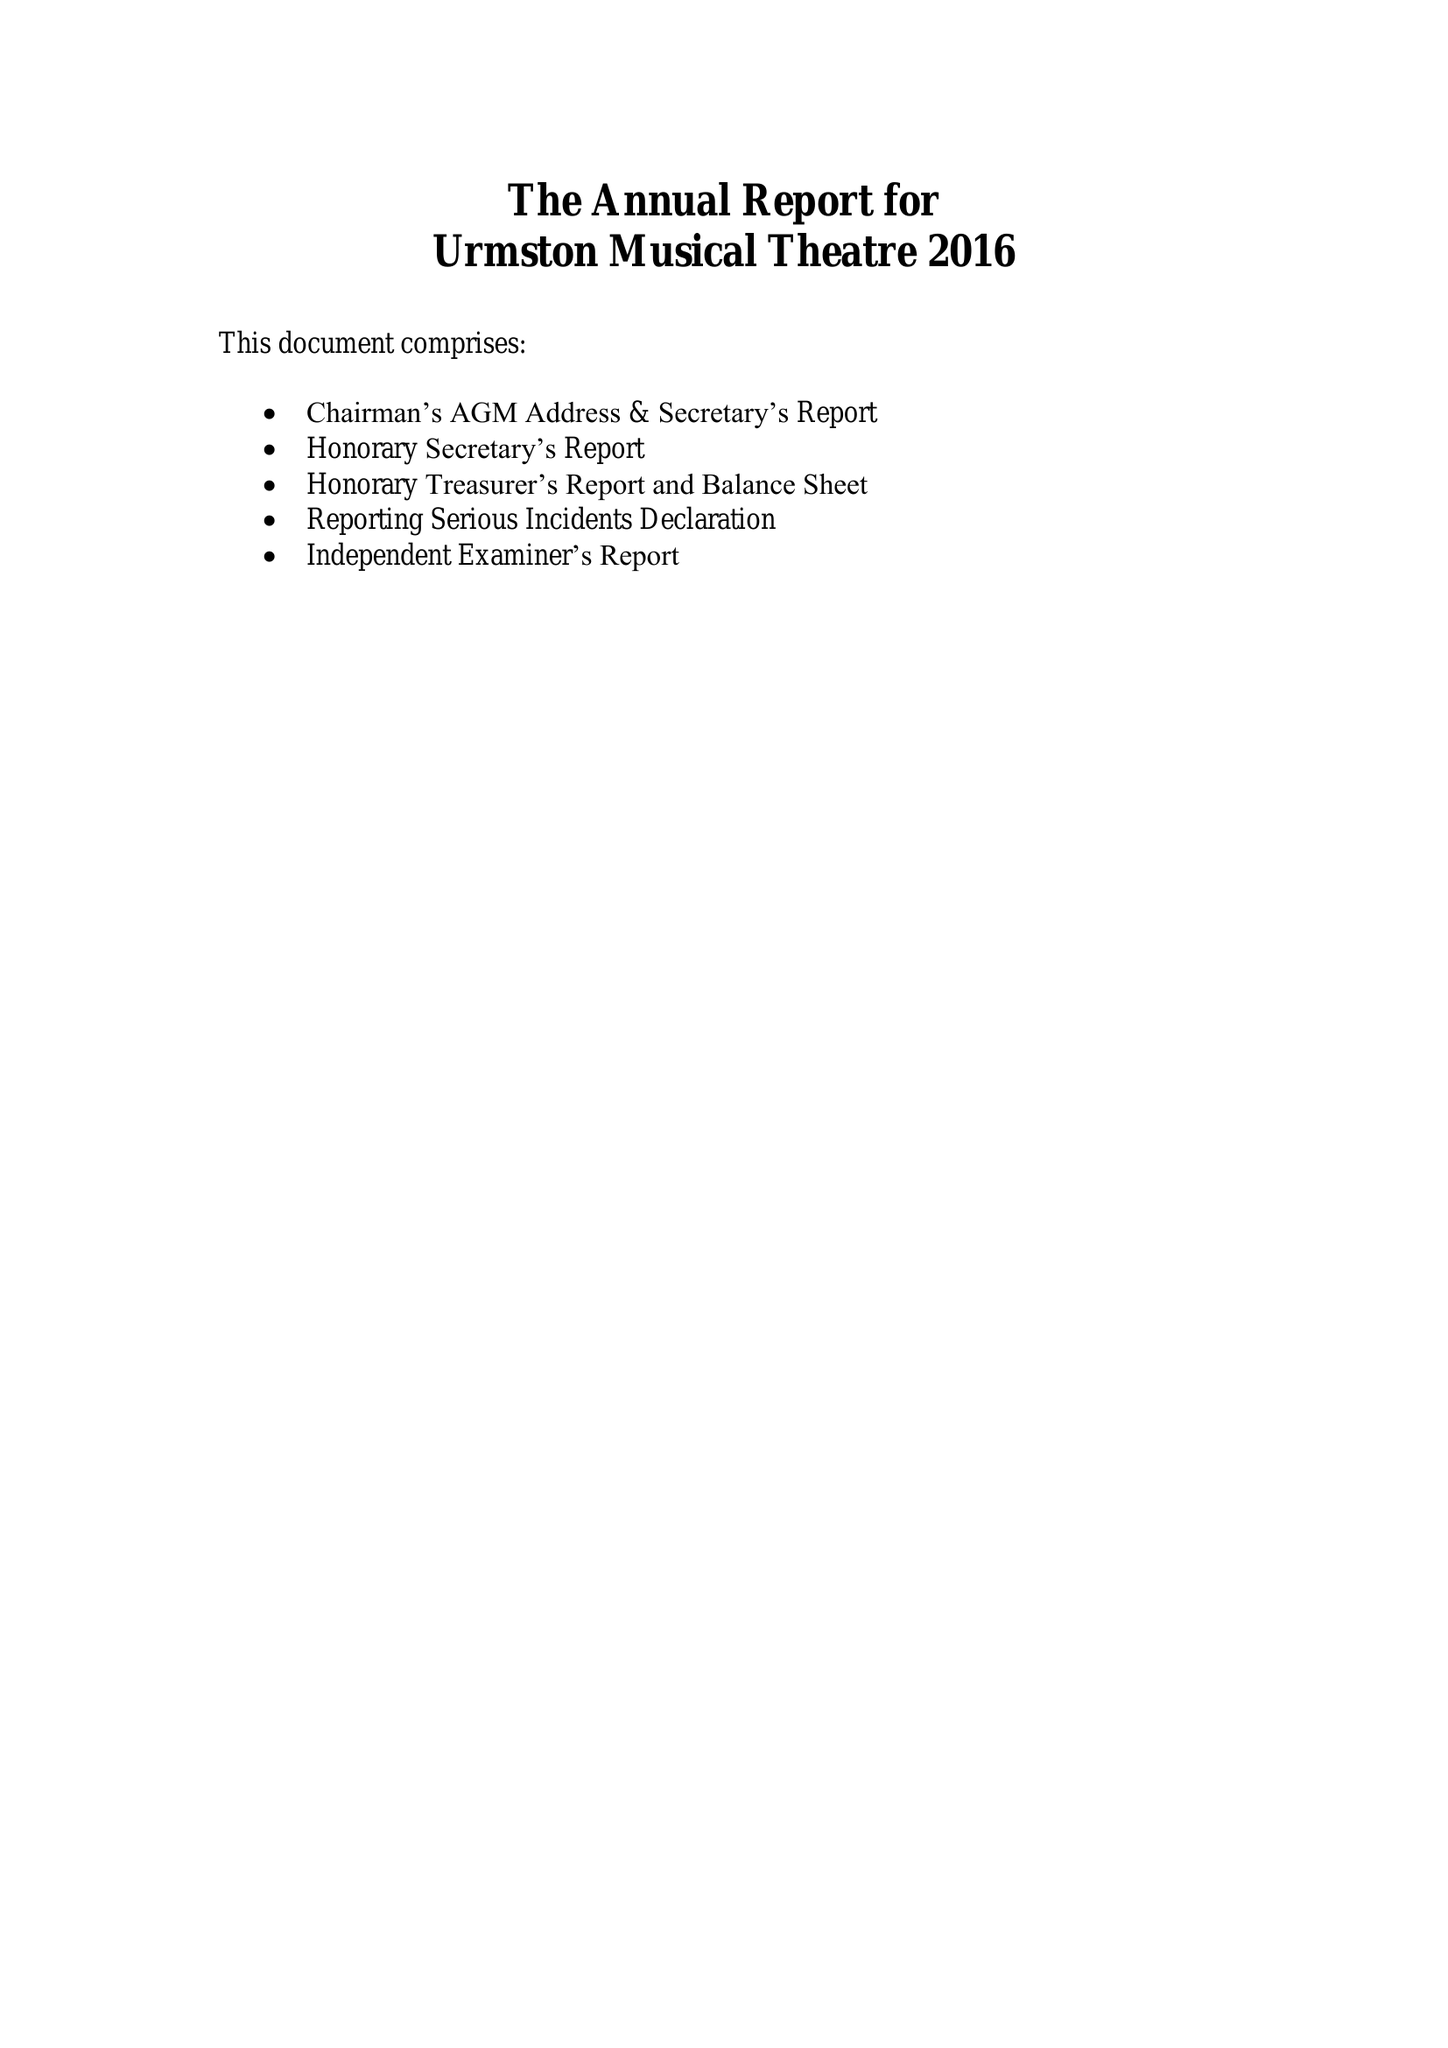What is the value for the address__postcode?
Answer the question using a single word or phrase. M41 5ST 